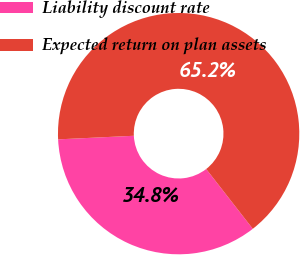Convert chart to OTSL. <chart><loc_0><loc_0><loc_500><loc_500><pie_chart><fcel>Liability discount rate<fcel>Expected return on plan assets<nl><fcel>34.78%<fcel>65.22%<nl></chart> 